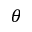<formula> <loc_0><loc_0><loc_500><loc_500>\theta</formula> 